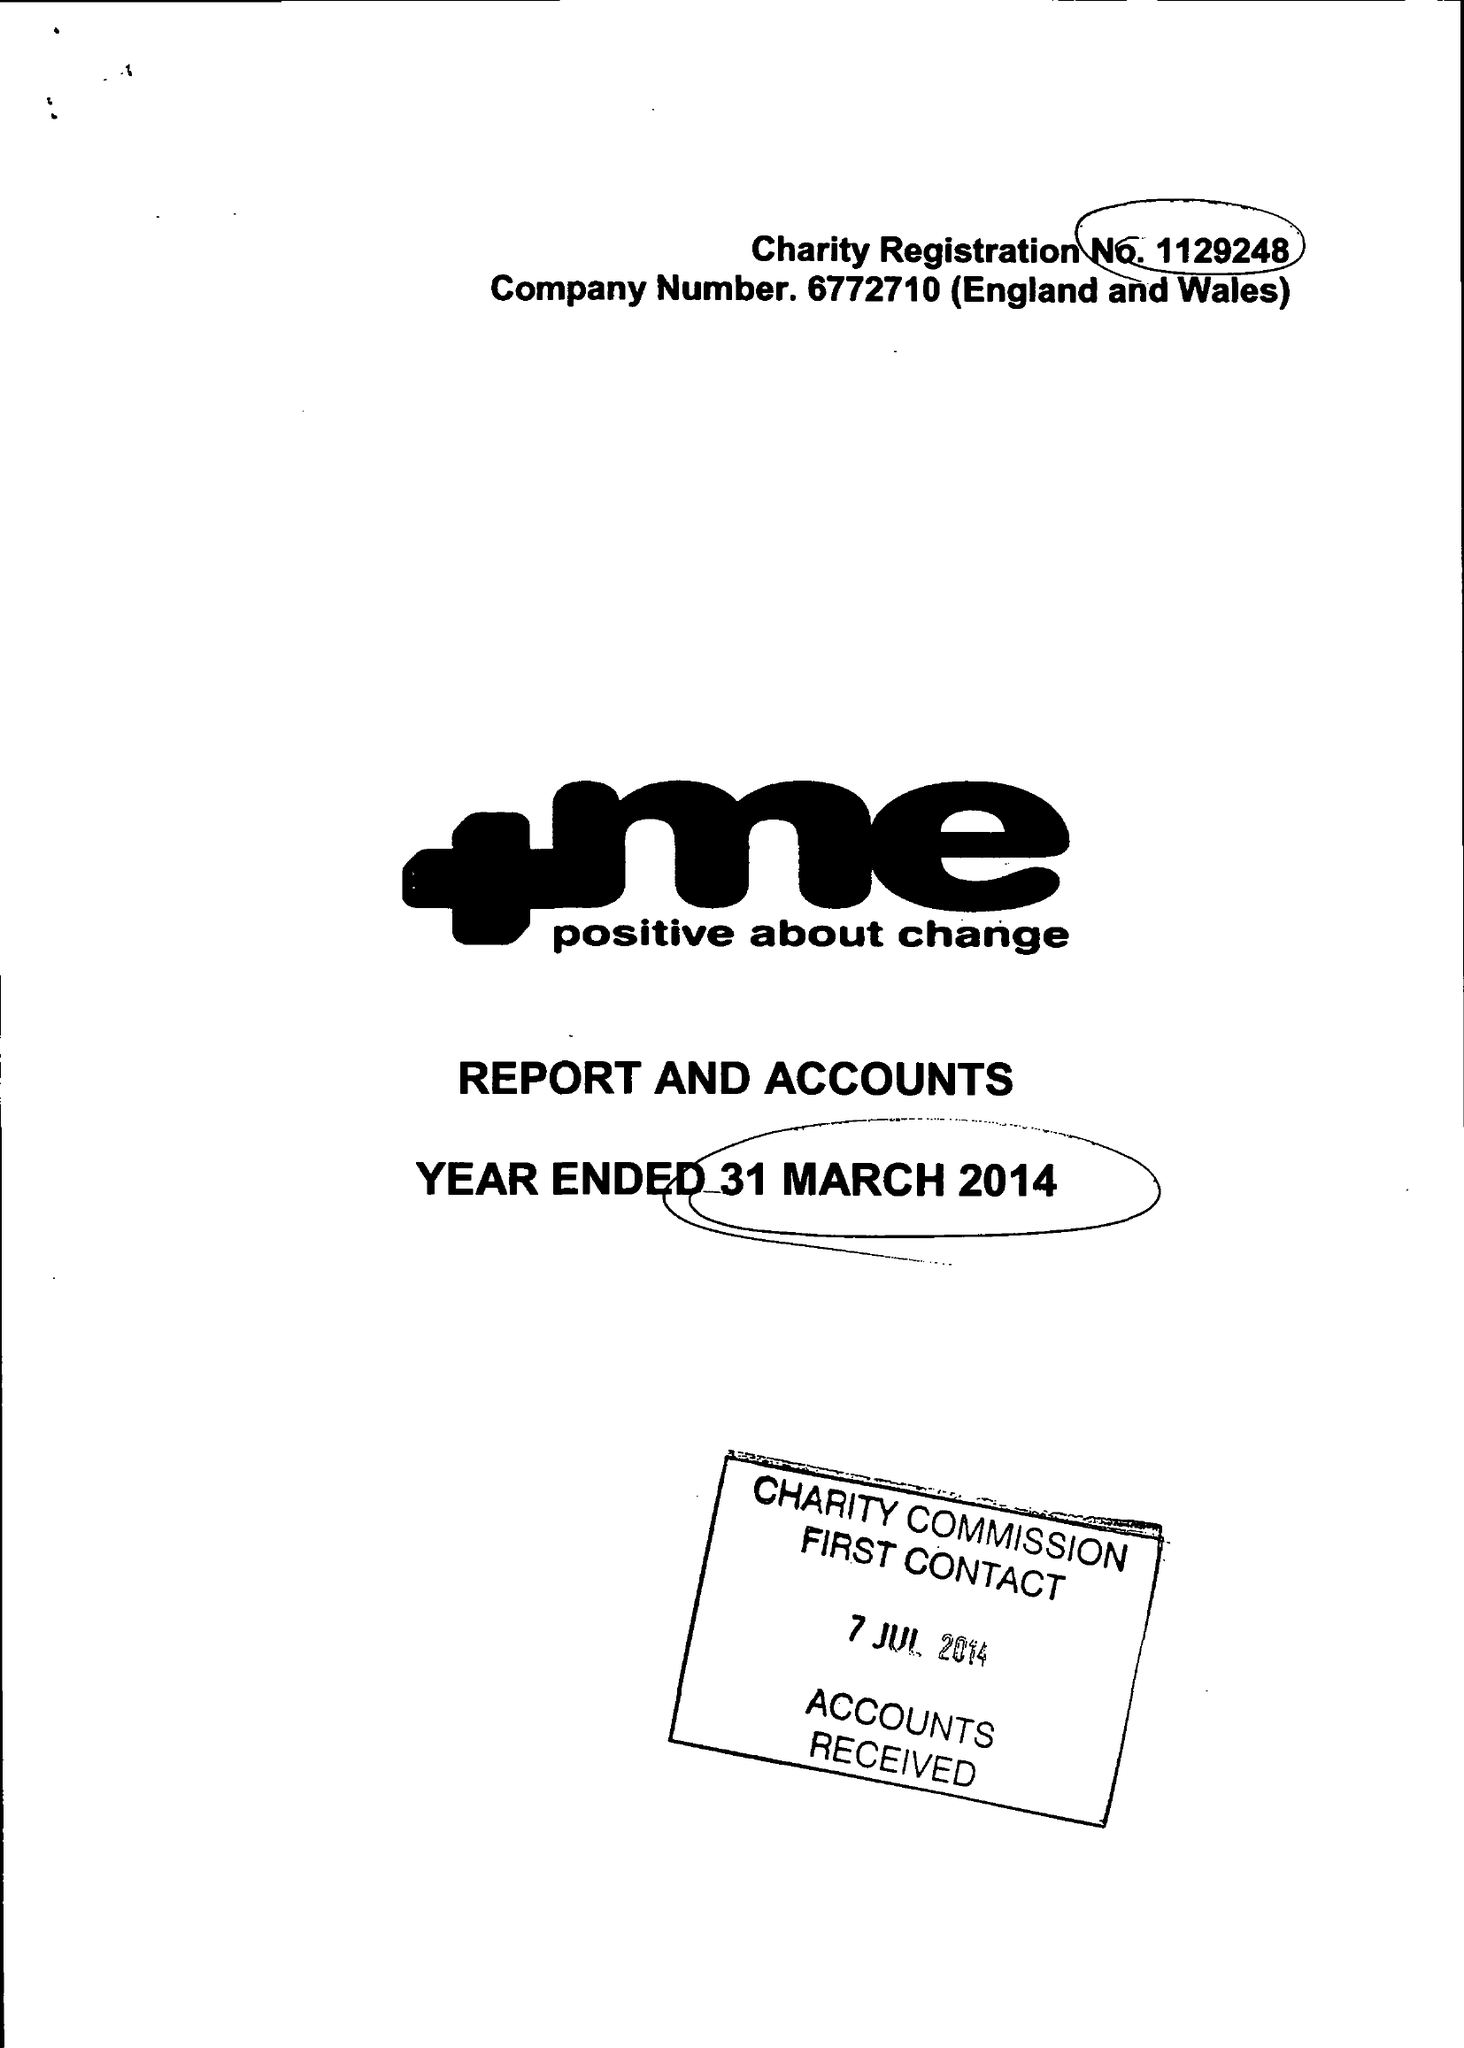What is the value for the charity_name?
Answer the question using a single word or phrase. +Me Positive About Change 